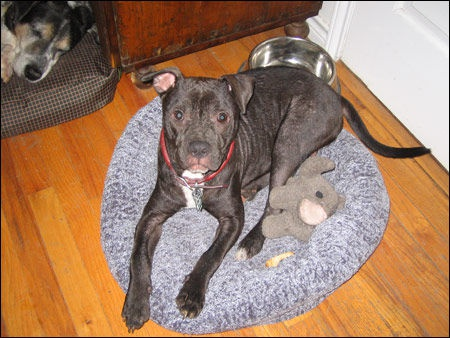Describe the objects in this image and their specific colors. I can see dog in black and gray tones, dog in black, gray, and darkgray tones, teddy bear in black, darkgray, lightgray, and gray tones, and bowl in black, gray, darkgray, lightgray, and maroon tones in this image. 